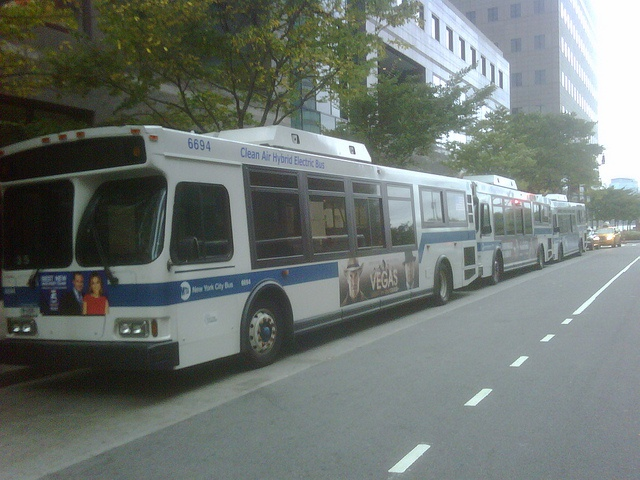Describe the objects in this image and their specific colors. I can see bus in black, darkgray, gray, and lightgray tones, people in black, maroon, olive, and gray tones, people in black and gray tones, people in black, maroon, and gray tones, and people in black and gray tones in this image. 